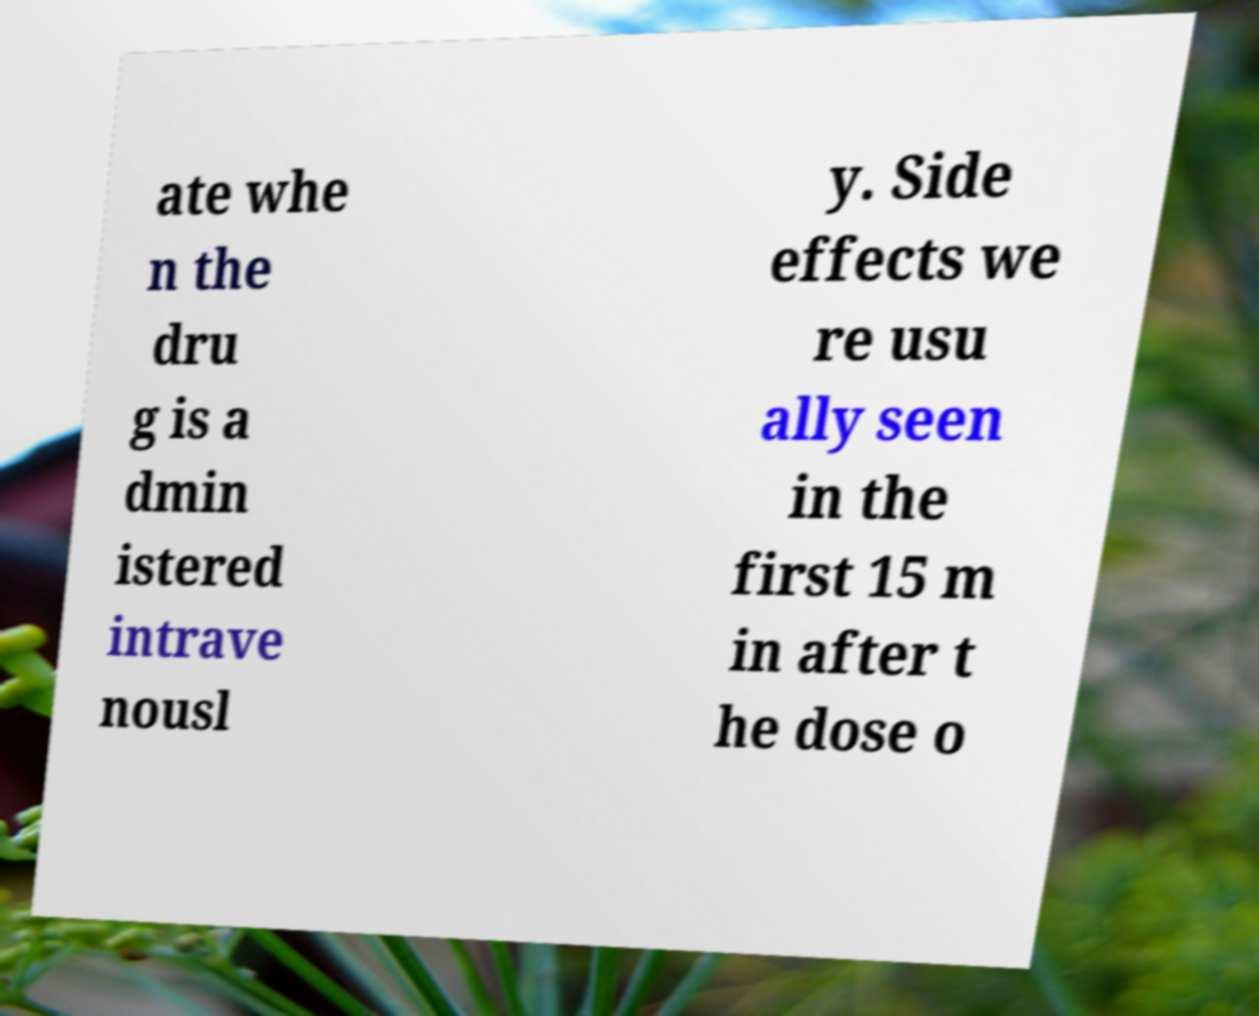I need the written content from this picture converted into text. Can you do that? ate whe n the dru g is a dmin istered intrave nousl y. Side effects we re usu ally seen in the first 15 m in after t he dose o 